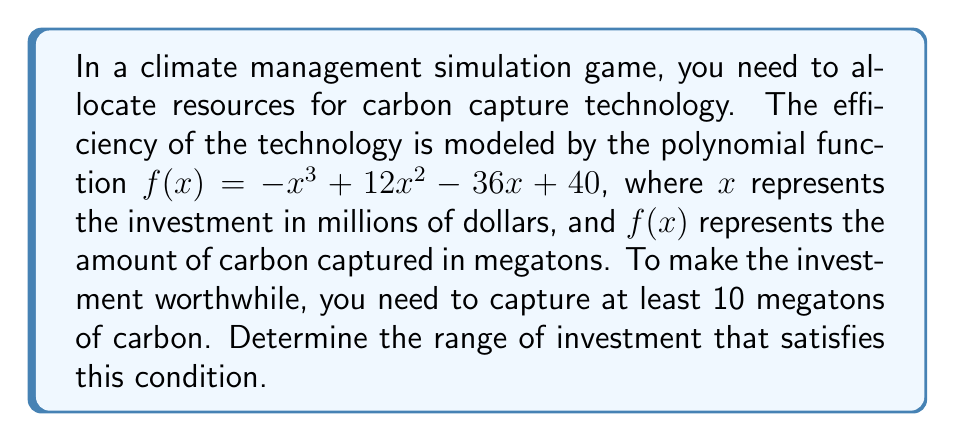Solve this math problem. To solve this problem, we need to find the values of $x$ that satisfy the inequality:

$$f(x) = -x^3 + 12x^2 - 36x + 40 \geq 10$$

Let's approach this step-by-step:

1) First, rearrange the inequality:
   $$-x^3 + 12x^2 - 36x + 30 \geq 0$$

2) Factor out the left side:
   $$-(x^3 - 12x^2 + 36x - 30) \geq 0$$
   $$-(x - 2)(x^2 - 10x + 15) \geq 0$$
   $$-(x - 2)(x - 5)(x - 5) \geq 0$$

3) The inequality will be satisfied when this expression is non-negative. This occurs when:
   - The negative sign is paired with a negative or zero result from $(x - 2)(x - 5)^2$, or
   - The negative sign is paired with a positive result from $(x - 2)(x - 5)^2$

4) Analyze the factors:
   - $(x - 2)$ is negative when $x < 2$, zero when $x = 2$, and positive when $x > 2$
   - $(x - 5)^2$ is always non-negative, and zero only when $x = 5$

5) Combining these conditions:
   - When $x \leq 2$, the expression is non-negative
   - When $2 < x < 5$, the expression is negative
   - When $x \geq 5$, the expression is non-negative

Therefore, the solution to the inequality is $x \leq 2$ or $x \geq 5$.
Answer: The optimal range of investment is $x \leq 2$ or $x \geq 5$ million dollars. 